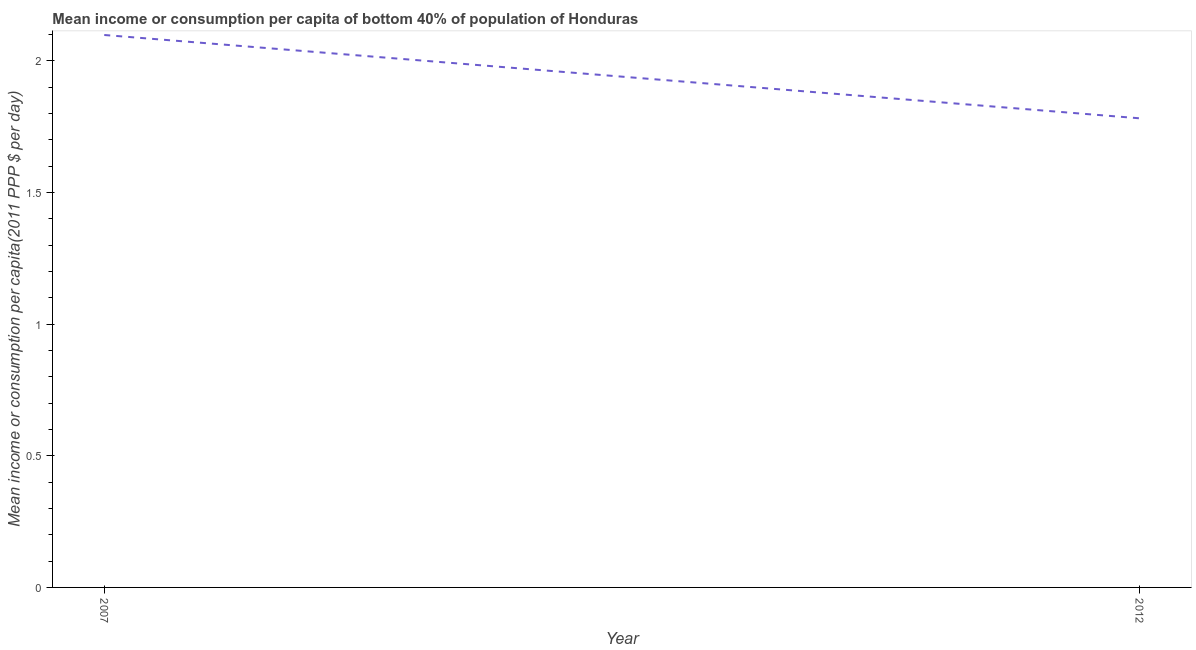What is the mean income or consumption in 2012?
Make the answer very short. 1.78. Across all years, what is the maximum mean income or consumption?
Make the answer very short. 2.1. Across all years, what is the minimum mean income or consumption?
Offer a terse response. 1.78. In which year was the mean income or consumption maximum?
Provide a succinct answer. 2007. In which year was the mean income or consumption minimum?
Make the answer very short. 2012. What is the sum of the mean income or consumption?
Ensure brevity in your answer.  3.88. What is the difference between the mean income or consumption in 2007 and 2012?
Your answer should be very brief. 0.32. What is the average mean income or consumption per year?
Your response must be concise. 1.94. What is the median mean income or consumption?
Ensure brevity in your answer.  1.94. In how many years, is the mean income or consumption greater than 1 $?
Your answer should be compact. 2. What is the ratio of the mean income or consumption in 2007 to that in 2012?
Provide a succinct answer. 1.18. Is the mean income or consumption in 2007 less than that in 2012?
Give a very brief answer. No. Are the values on the major ticks of Y-axis written in scientific E-notation?
Your answer should be compact. No. Does the graph contain any zero values?
Give a very brief answer. No. Does the graph contain grids?
Offer a terse response. No. What is the title of the graph?
Your answer should be very brief. Mean income or consumption per capita of bottom 40% of population of Honduras. What is the label or title of the Y-axis?
Your answer should be very brief. Mean income or consumption per capita(2011 PPP $ per day). What is the Mean income or consumption per capita(2011 PPP $ per day) in 2007?
Ensure brevity in your answer.  2.1. What is the Mean income or consumption per capita(2011 PPP $ per day) of 2012?
Your answer should be compact. 1.78. What is the difference between the Mean income or consumption per capita(2011 PPP $ per day) in 2007 and 2012?
Provide a short and direct response. 0.32. What is the ratio of the Mean income or consumption per capita(2011 PPP $ per day) in 2007 to that in 2012?
Give a very brief answer. 1.18. 